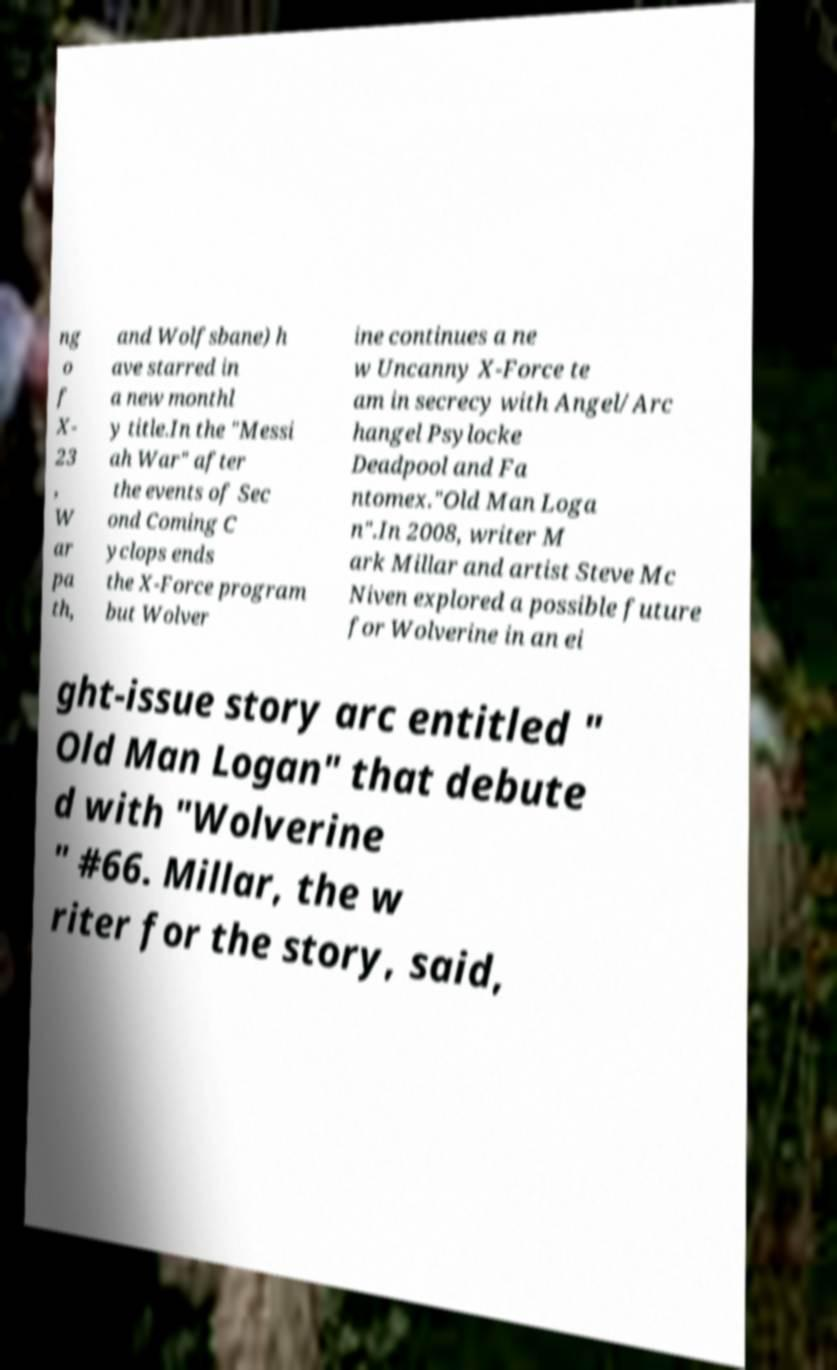Can you read and provide the text displayed in the image?This photo seems to have some interesting text. Can you extract and type it out for me? ng o f X- 23 , W ar pa th, and Wolfsbane) h ave starred in a new monthl y title.In the "Messi ah War" after the events of Sec ond Coming C yclops ends the X-Force program but Wolver ine continues a ne w Uncanny X-Force te am in secrecy with Angel/Arc hangel Psylocke Deadpool and Fa ntomex."Old Man Loga n".In 2008, writer M ark Millar and artist Steve Mc Niven explored a possible future for Wolverine in an ei ght-issue story arc entitled " Old Man Logan" that debute d with "Wolverine " #66. Millar, the w riter for the story, said, 